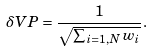Convert formula to latex. <formula><loc_0><loc_0><loc_500><loc_500>\delta V P = \frac { 1 } { \sqrt { \sum _ { i = 1 , N } w _ { i } } } .</formula> 